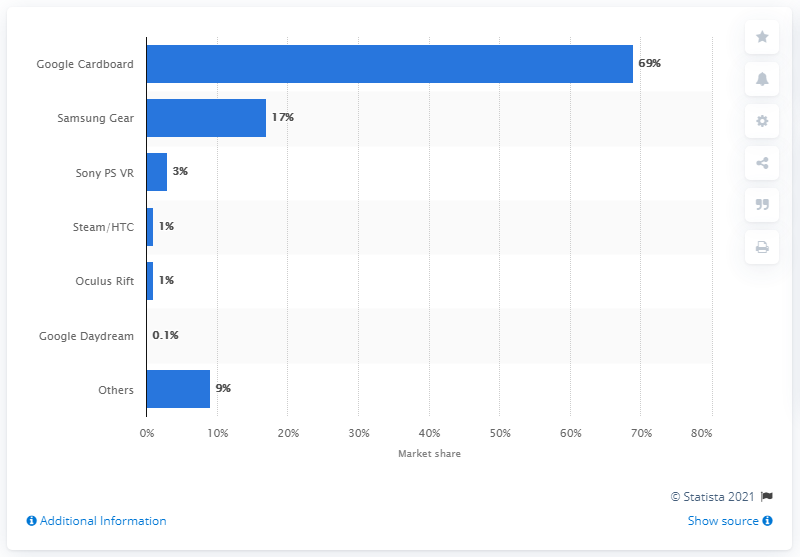List a handful of essential elements in this visual. In 2016, Google Cardboard accounted for 69% of all VR headset shipments worldwide. 